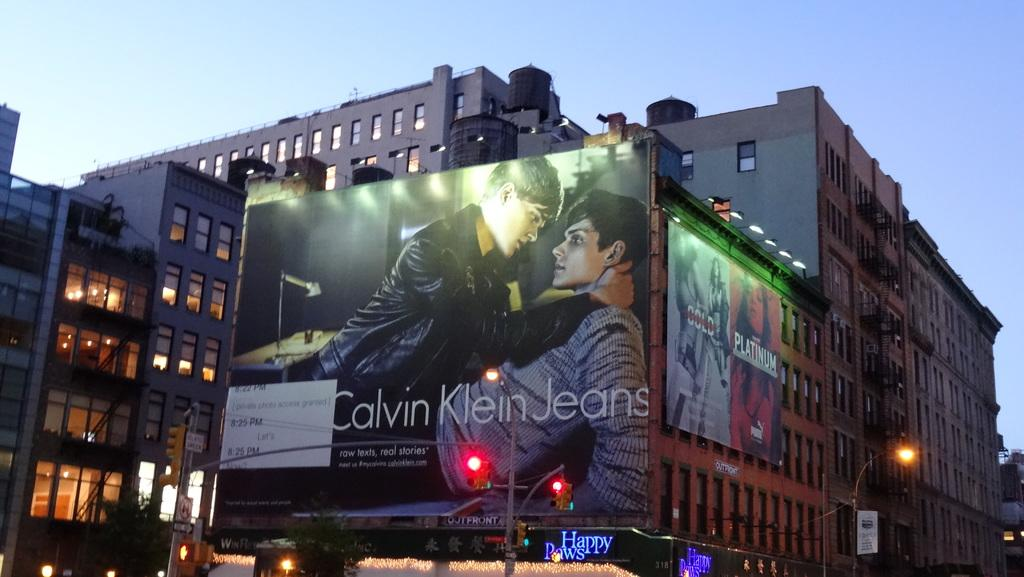<image>
Present a compact description of the photo's key features. Tall buildings that are grey and brown colored with a giant billboard on one that says Calvin Klein Jeans. 